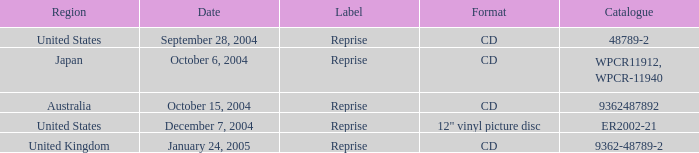Name the label for january 24, 2005 Reprise. 